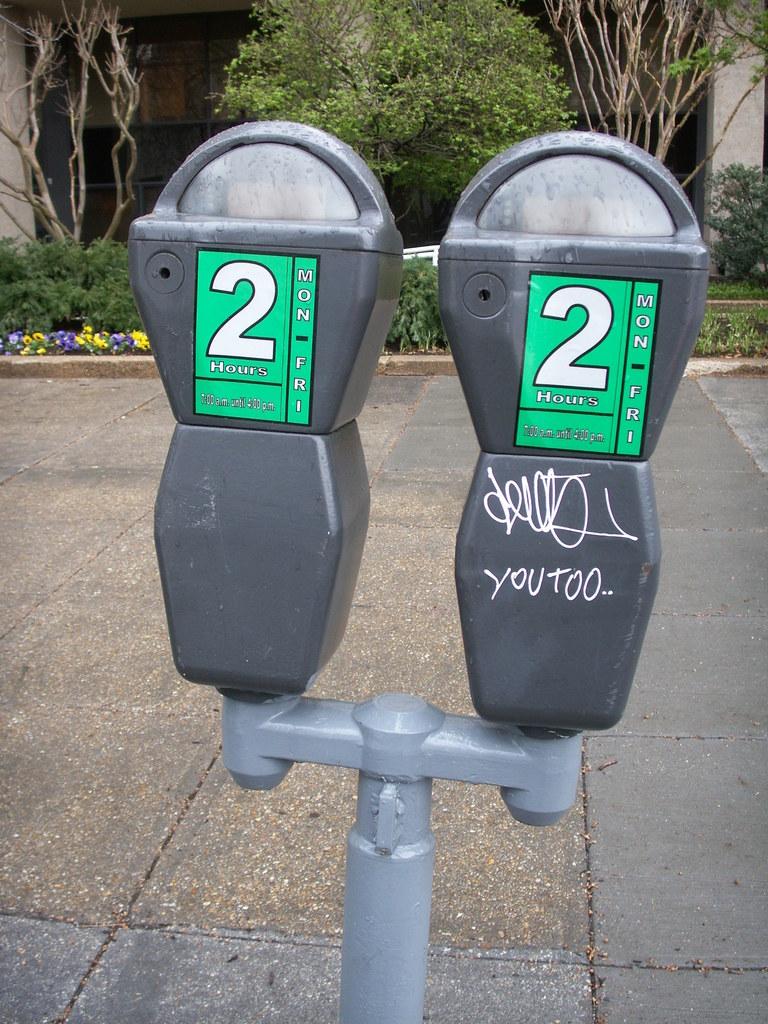What did someone write on one of the parking meters?
Your response must be concise. You too. How long can this meter be used?
Offer a very short reply. 2 hours. 